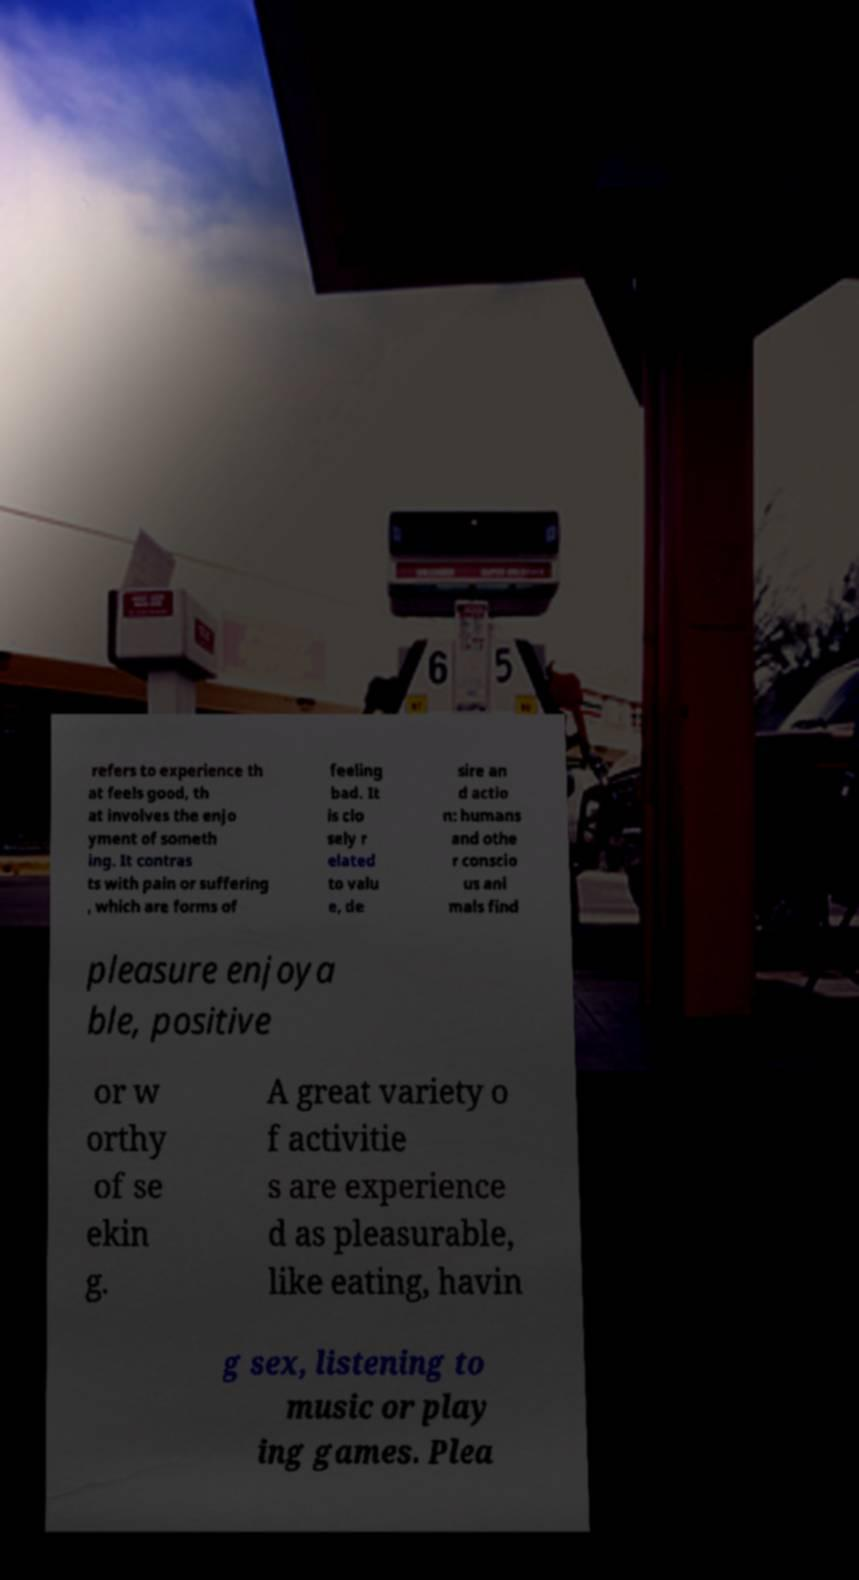There's text embedded in this image that I need extracted. Can you transcribe it verbatim? refers to experience th at feels good, th at involves the enjo yment of someth ing. It contras ts with pain or suffering , which are forms of feeling bad. It is clo sely r elated to valu e, de sire an d actio n: humans and othe r conscio us ani mals find pleasure enjoya ble, positive or w orthy of se ekin g. A great variety o f activitie s are experience d as pleasurable, like eating, havin g sex, listening to music or play ing games. Plea 